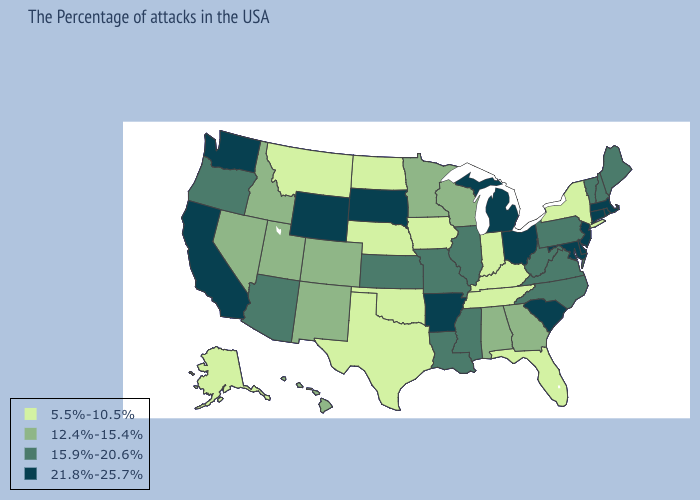Does Nebraska have the highest value in the MidWest?
Short answer required. No. What is the value of Texas?
Concise answer only. 5.5%-10.5%. Which states have the lowest value in the South?
Quick response, please. Florida, Kentucky, Tennessee, Oklahoma, Texas. Name the states that have a value in the range 12.4%-15.4%?
Short answer required. Georgia, Alabama, Wisconsin, Minnesota, Colorado, New Mexico, Utah, Idaho, Nevada, Hawaii. Among the states that border Maine , which have the highest value?
Be succinct. New Hampshire. What is the lowest value in states that border Nebraska?
Quick response, please. 5.5%-10.5%. Does Kansas have a higher value than Washington?
Concise answer only. No. What is the highest value in the USA?
Write a very short answer. 21.8%-25.7%. Does Mississippi have the lowest value in the South?
Quick response, please. No. Among the states that border Indiana , which have the lowest value?
Concise answer only. Kentucky. Name the states that have a value in the range 21.8%-25.7%?
Give a very brief answer. Massachusetts, Rhode Island, Connecticut, New Jersey, Delaware, Maryland, South Carolina, Ohio, Michigan, Arkansas, South Dakota, Wyoming, California, Washington. Which states have the highest value in the USA?
Answer briefly. Massachusetts, Rhode Island, Connecticut, New Jersey, Delaware, Maryland, South Carolina, Ohio, Michigan, Arkansas, South Dakota, Wyoming, California, Washington. What is the value of Pennsylvania?
Give a very brief answer. 15.9%-20.6%. Name the states that have a value in the range 5.5%-10.5%?
Give a very brief answer. New York, Florida, Kentucky, Indiana, Tennessee, Iowa, Nebraska, Oklahoma, Texas, North Dakota, Montana, Alaska. Which states have the highest value in the USA?
Concise answer only. Massachusetts, Rhode Island, Connecticut, New Jersey, Delaware, Maryland, South Carolina, Ohio, Michigan, Arkansas, South Dakota, Wyoming, California, Washington. 